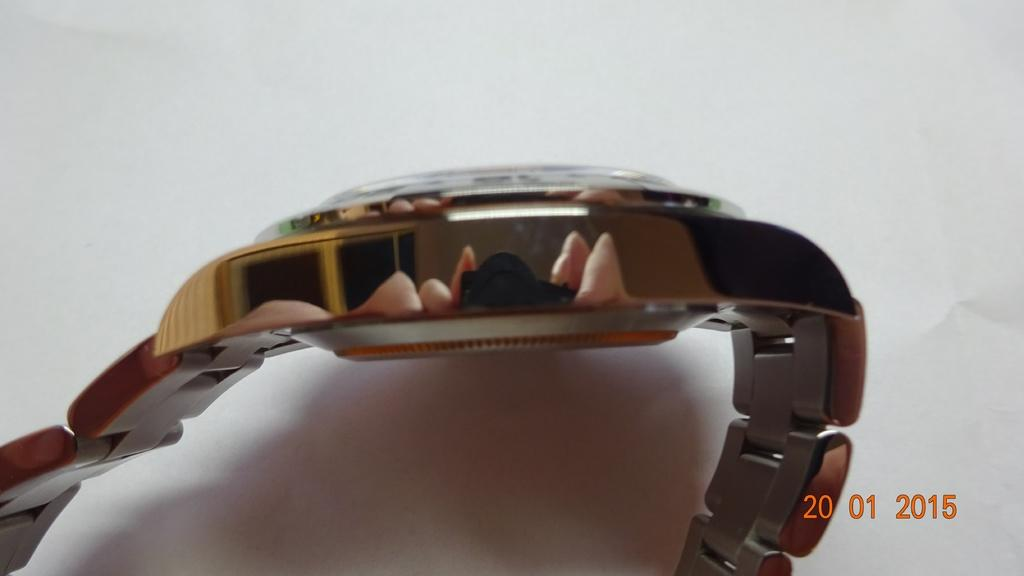What is the main object in the image? There is a golden watch in the image. How is the golden watch positioned in the image? The golden watch is placed on a white paper. Is there any additional information provided in the image? Yes, there is a small date mentioned on the bottom right side of the image. What type of crate is visible in the image? There is no crate present in the image. What is the smell of the golden watch in the image? The image does not provide any information about the smell of the golden watch. 